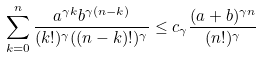<formula> <loc_0><loc_0><loc_500><loc_500>\sum _ { k = 0 } ^ { n } \frac { a ^ { \gamma k } b ^ { \gamma ( n - k ) } } { ( k ! ) ^ { \gamma } ( ( n - k ) ! ) ^ { \gamma } } \leq c _ { \gamma } \frac { ( a + b ) ^ { \gamma n } } { ( n ! ) ^ { \gamma } }</formula> 